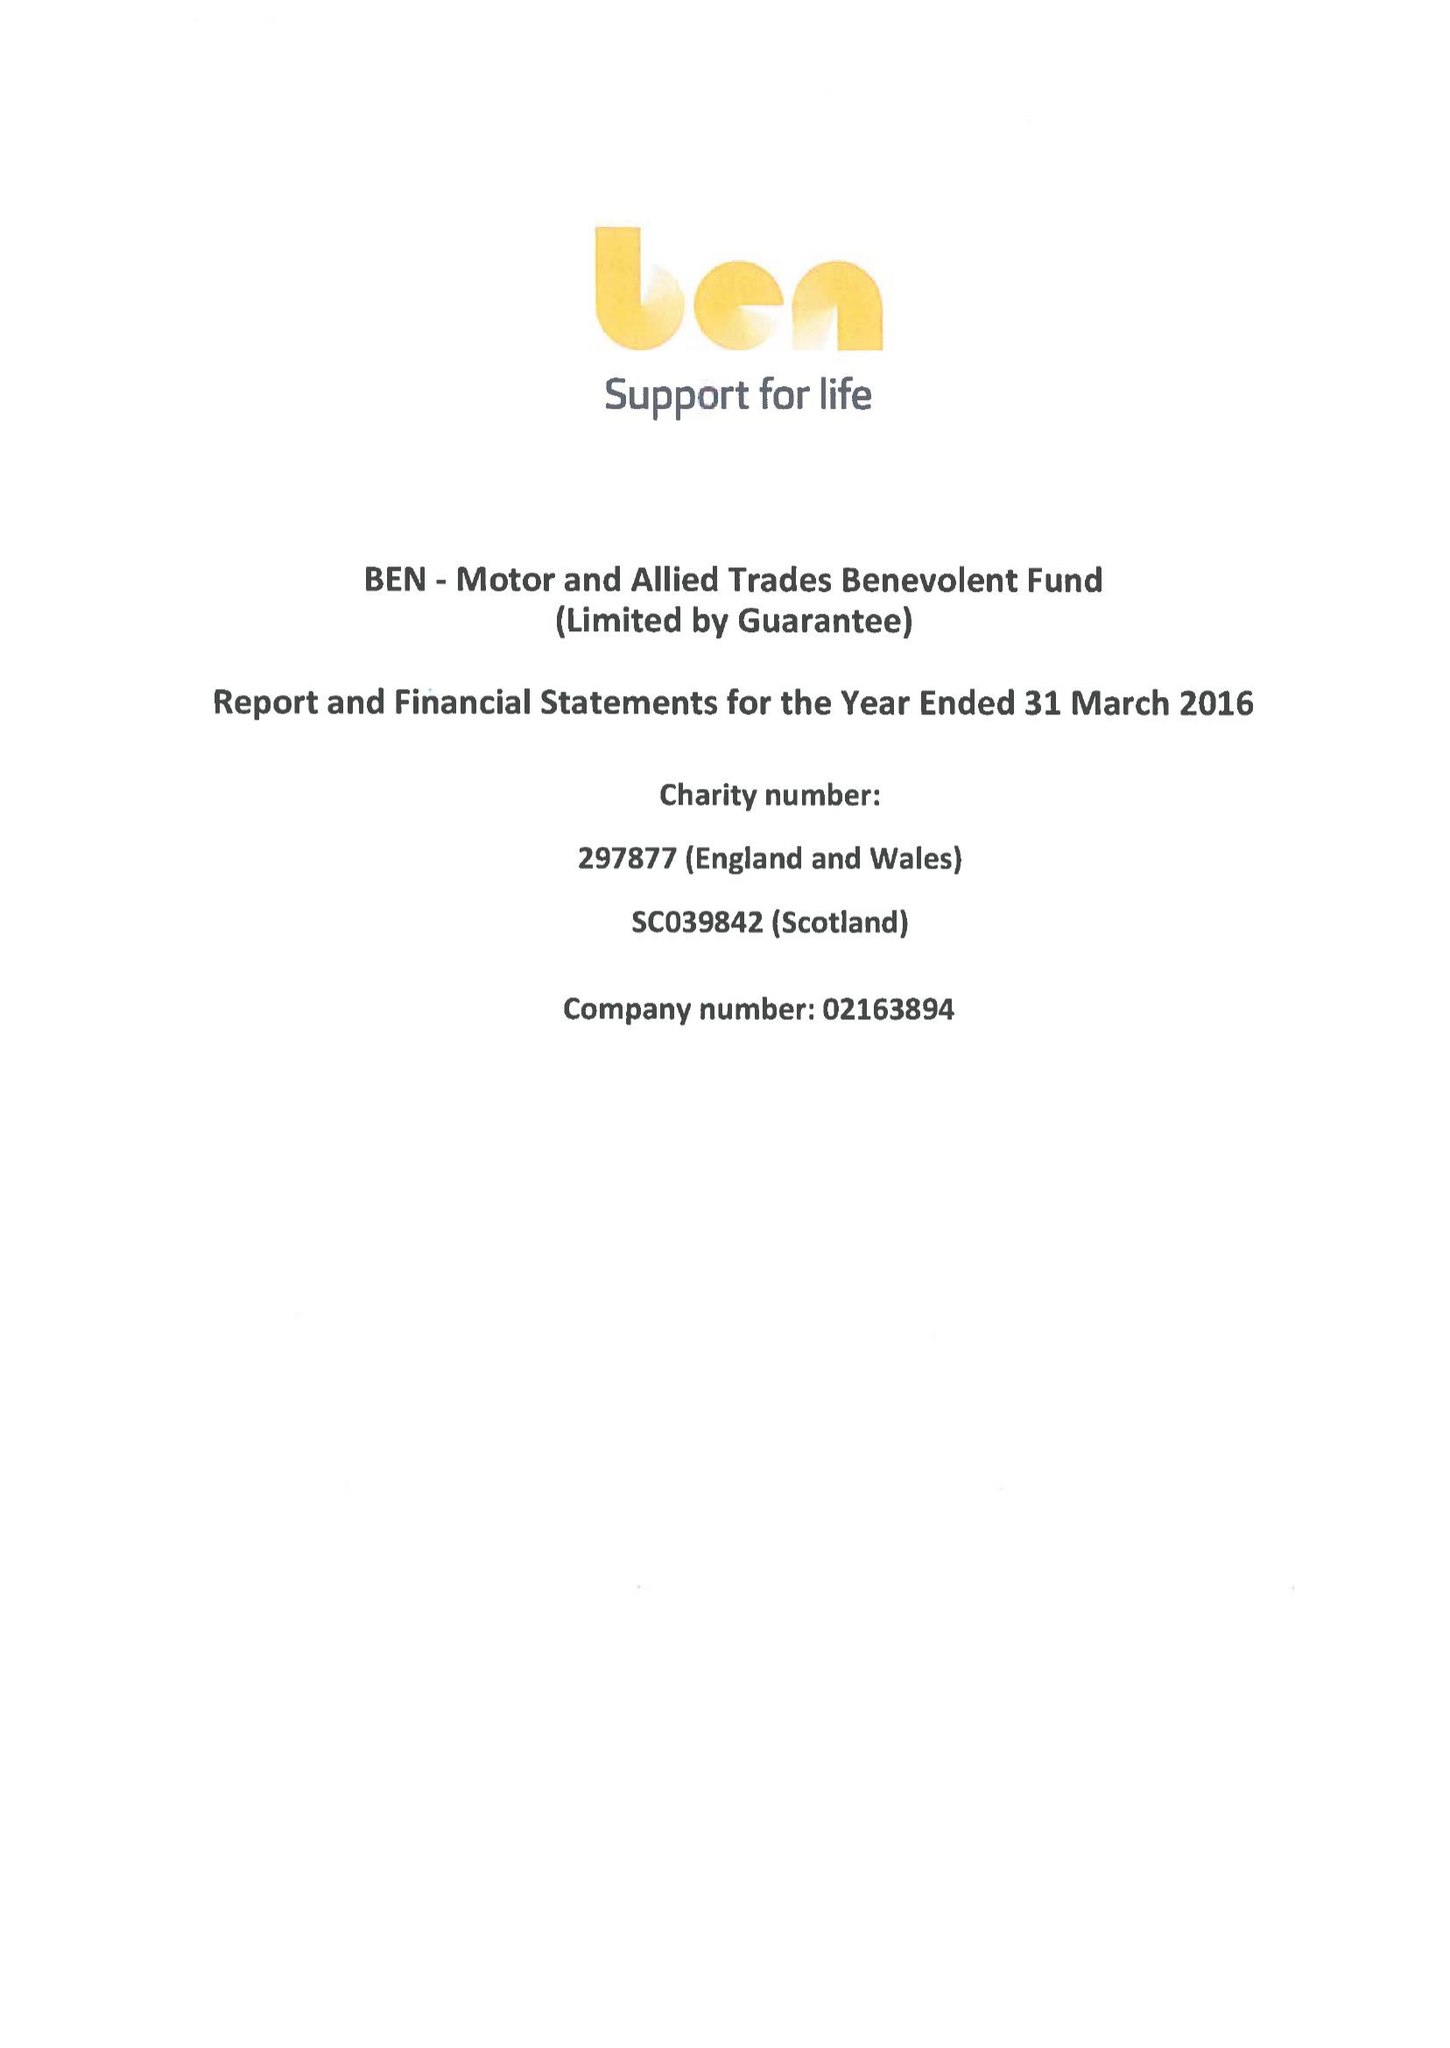What is the value for the address__postcode?
Answer the question using a single word or phrase. SL5 0FG 